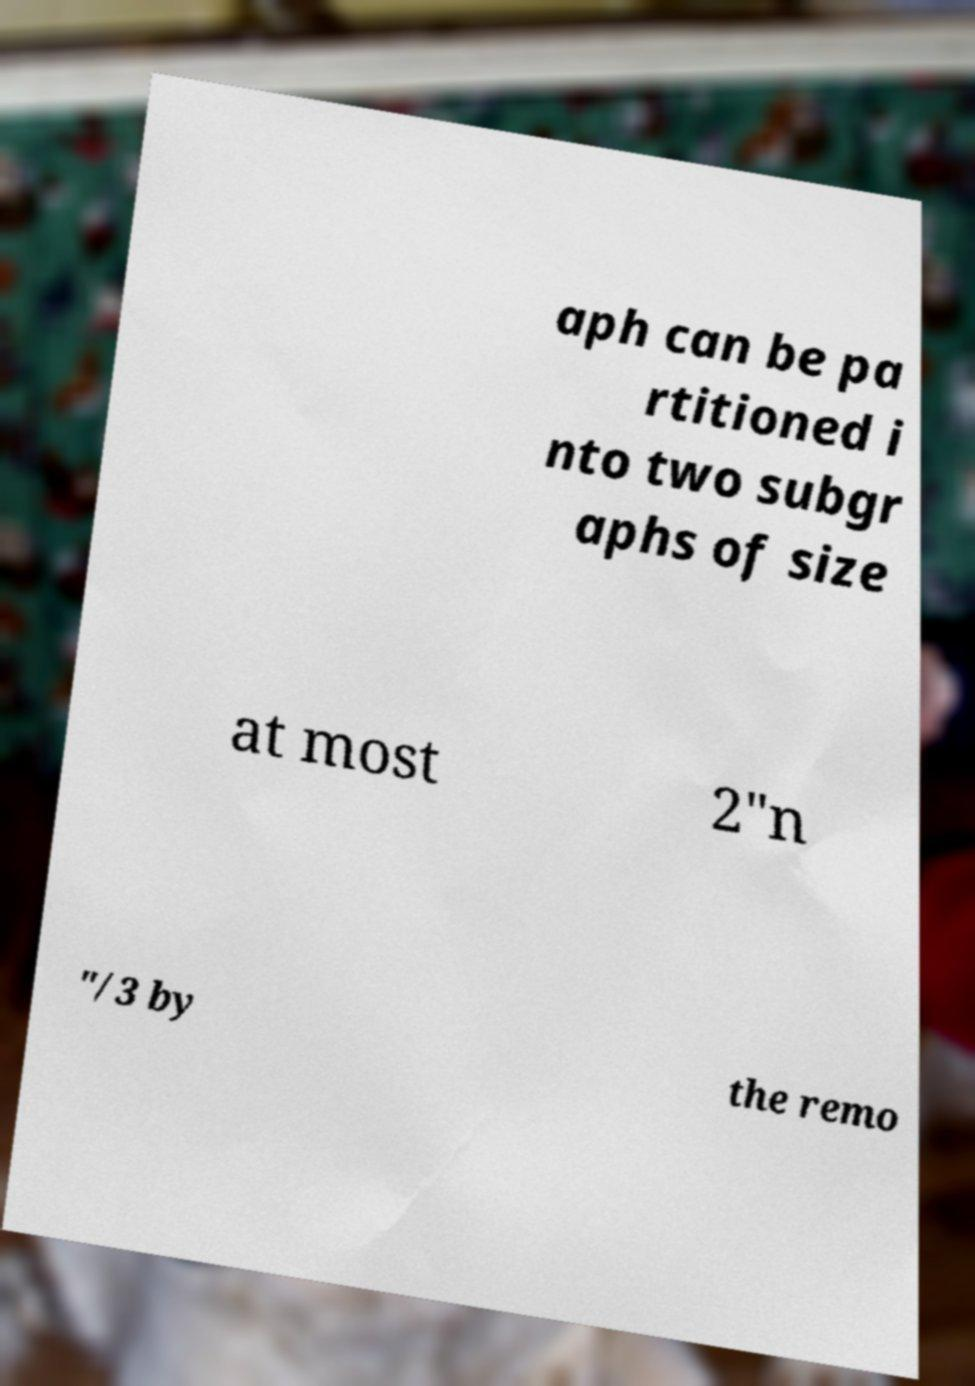Could you extract and type out the text from this image? aph can be pa rtitioned i nto two subgr aphs of size at most 2"n "/3 by the remo 